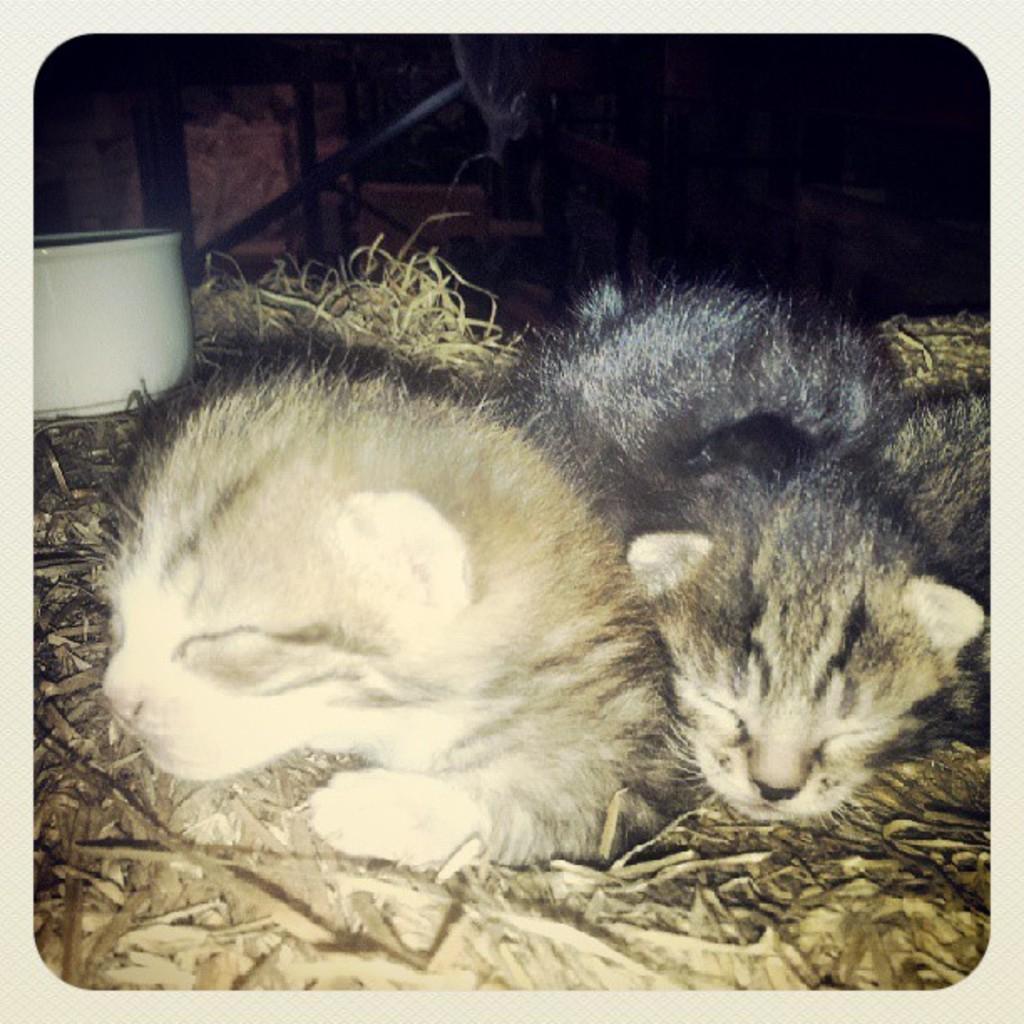Describe this image in one or two sentences. In the image there are two kittens lying on the grass. Behind them on the left side there is a white color object. There are some other things in the background. 